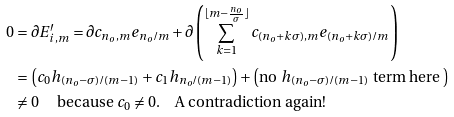Convert formula to latex. <formula><loc_0><loc_0><loc_500><loc_500>0 & = \partial E ^ { \prime } _ { i , m } = \partial c _ { n _ { o } , m } e _ { n _ { o } / m } + \partial \left ( \sum _ { k = 1 } ^ { \lfloor m - \frac { n _ { o } } { \sigma } \rfloor } c _ { ( n _ { o } + k \sigma ) , m } e _ { ( n _ { o } + k \sigma ) / m } \right ) \\ & = \left ( c _ { 0 } h _ { ( n _ { o } - \sigma ) / ( m - 1 ) } + c _ { 1 } h _ { n _ { o } / ( m - 1 ) } \right ) + \left ( \text {no $h_{(n_{o}-\sigma)/(m-1)}$ term here } \right ) \\ & \neq 0 \quad \text { because $c_{0}\neq 0$} . \quad \text {A contradiction again!}</formula> 